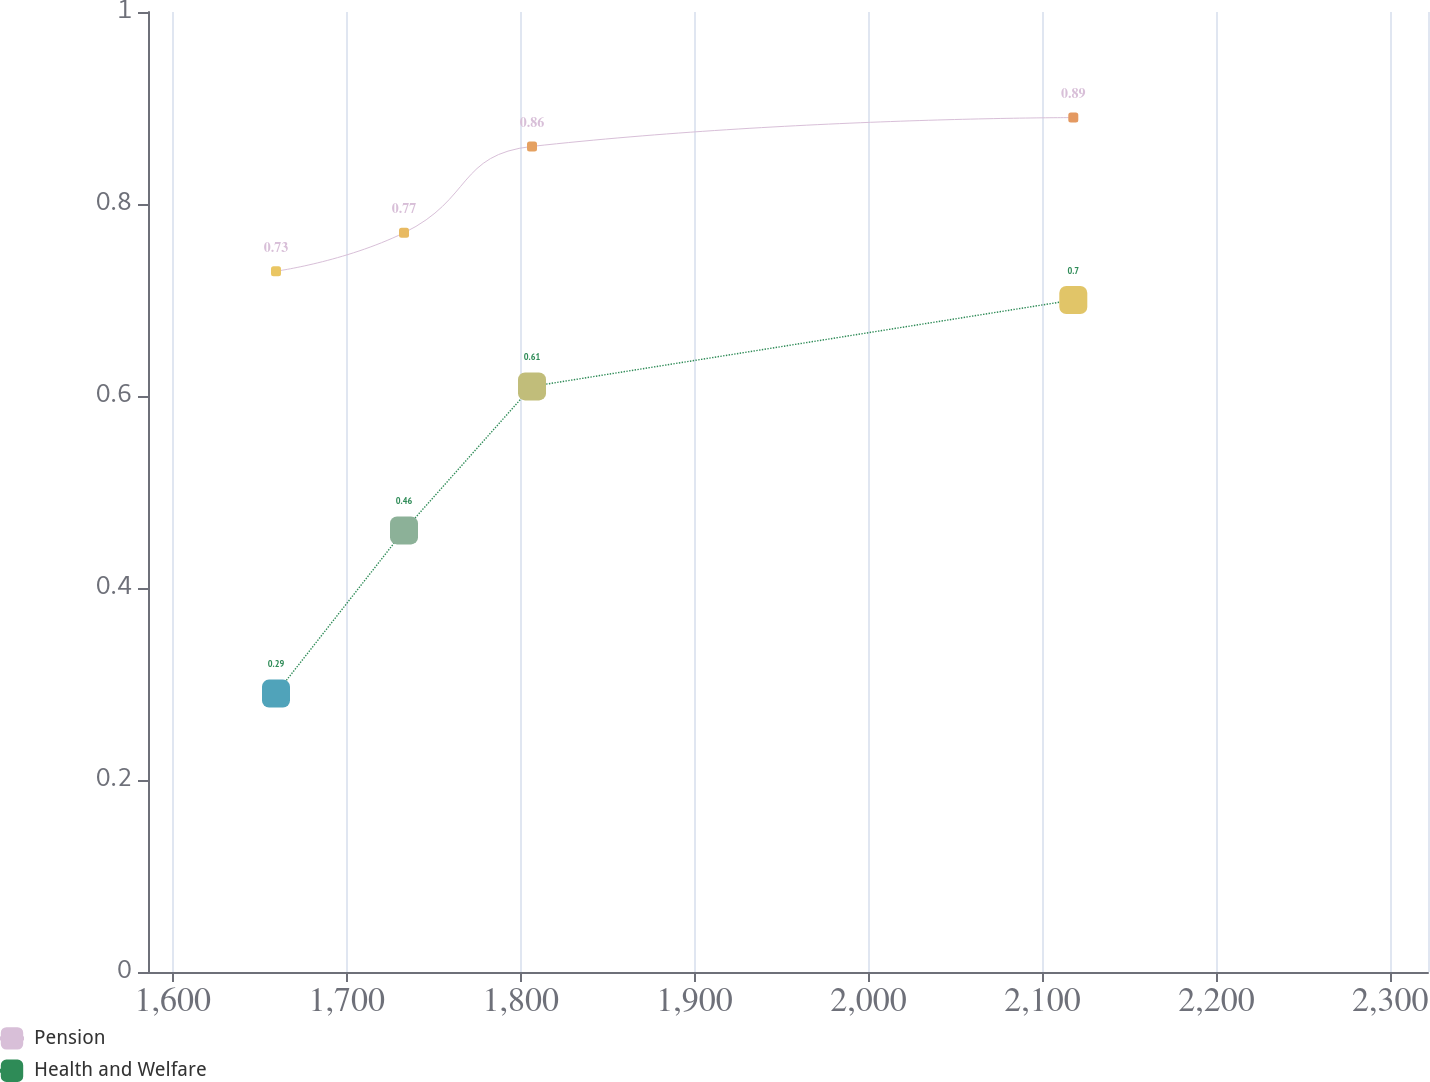<chart> <loc_0><loc_0><loc_500><loc_500><line_chart><ecel><fcel>Pension<fcel>Health and Welfare<nl><fcel>1659.31<fcel>0.73<fcel>0.29<nl><fcel>1732.91<fcel>0.77<fcel>0.46<nl><fcel>1806.51<fcel>0.86<fcel>0.61<nl><fcel>2117.73<fcel>0.89<fcel>0.7<nl><fcel>2395.27<fcel>0.82<fcel>1.16<nl></chart> 